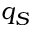Convert formula to latex. <formula><loc_0><loc_0><loc_500><loc_500>q _ { S }</formula> 